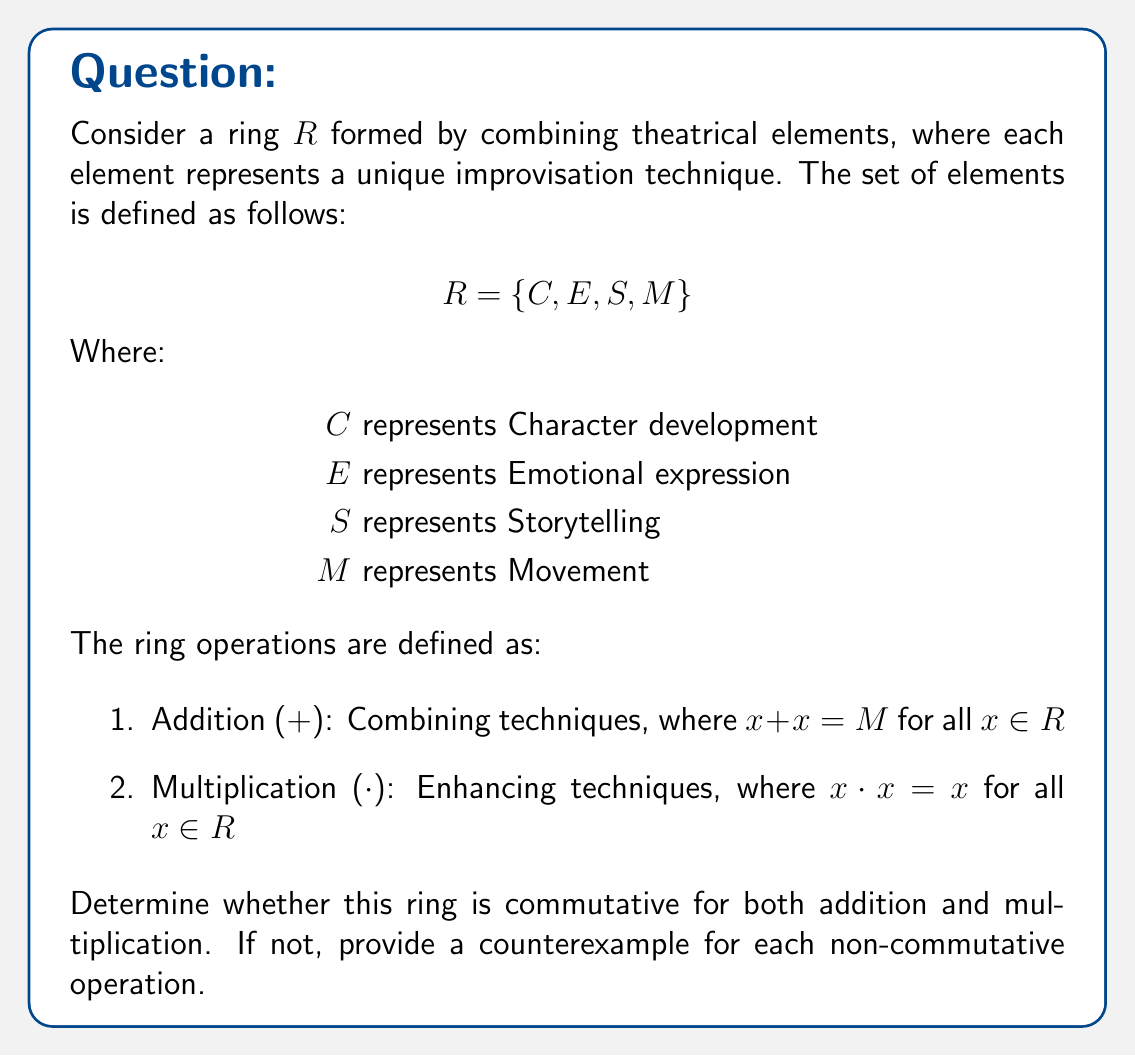Teach me how to tackle this problem. To determine if the ring is commutative for both addition and multiplication, we need to check if $a + b = b + a$ and $a \cdot b = b \cdot a$ for all $a, b \in R$.

1. Commutativity of addition:
   We need to check all possible pairs of elements:
   
   $C + E = E + C$
   $C + S = S + C$
   $C + M = M + C$
   $E + S = S + E$
   $E + M = M + E$
   $S + M = M + S$
   
   Since the addition operation is defined as combining techniques, and $x + x = M$ for all $x \in R$, we can conclude that addition is commutative for all pairs of elements.

2. Commutativity of multiplication:
   We need to check all possible pairs of elements:
   
   $C \cdot E$ vs $E \cdot C$
   $C \cdot S$ vs $S \cdot C$
   $C \cdot M$ vs $M \cdot C$
   $E \cdot S$ vs $S \cdot E$
   $E \cdot M$ vs $M \cdot E$
   $S \cdot M$ vs $M \cdot S$
   
   The multiplication operation is defined as enhancing techniques, where $x \cdot x = x$ for all $x \in R$. However, we don't have enough information about how different elements interact when multiplied. Without a complete multiplication table, we cannot determine if multiplication is commutative for all pairs of elements.

   To provide a counterexample, let's assume that $C \cdot E = C$ (Character development enhanced by Emotional expression results in Character development) and $E \cdot C = E$ (Emotional expression enhanced by Character development results in Emotional expression).

   In this case, $C \cdot E \neq E \cdot C$, which would make multiplication non-commutative.
Answer: The ring $R$ is commutative for addition but not necessarily commutative for multiplication. A possible counterexample for non-commutativity of multiplication is $C \cdot E = C$ and $E \cdot C = E$, where $C \cdot E \neq E \cdot C$. 